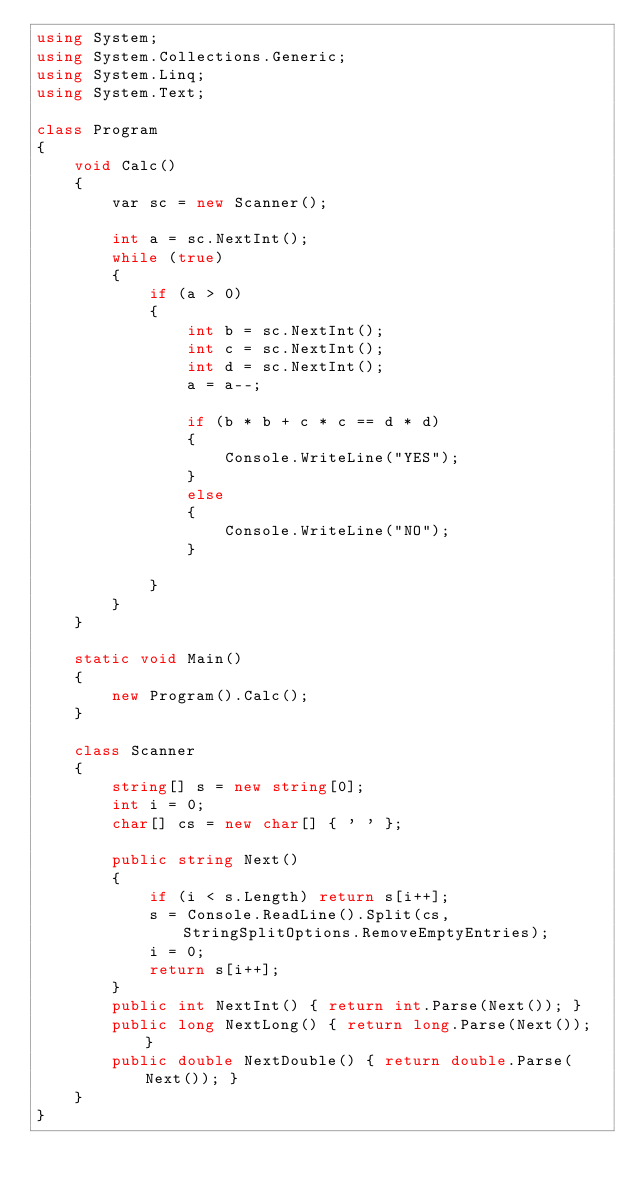Convert code to text. <code><loc_0><loc_0><loc_500><loc_500><_C#_>using System;
using System.Collections.Generic;
using System.Linq;
using System.Text;

class Program
{
    void Calc()
    {
        var sc = new Scanner();

        int a = sc.NextInt();
        while (true)
        {
            if (a > 0)
            {
                int b = sc.NextInt();
                int c = sc.NextInt();
                int d = sc.NextInt();
                a = a--;

                if (b * b + c * c == d * d)
                {
                    Console.WriteLine("YES");
                }
                else
                {
                    Console.WriteLine("NO");
                }

            }
        }
    }

    static void Main()
    {
        new Program().Calc();
    }

    class Scanner
    {
        string[] s = new string[0];
        int i = 0;
        char[] cs = new char[] { ' ' };

        public string Next()
        {
            if (i < s.Length) return s[i++];
            s = Console.ReadLine().Split(cs, StringSplitOptions.RemoveEmptyEntries);
            i = 0;
            return s[i++];
        }
        public int NextInt() { return int.Parse(Next()); }
        public long NextLong() { return long.Parse(Next()); }
        public double NextDouble() { return double.Parse(Next()); }
    }
}</code> 